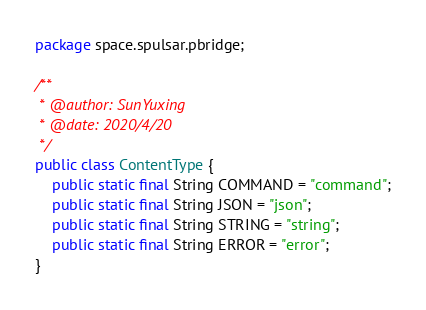<code> <loc_0><loc_0><loc_500><loc_500><_Java_>package space.spulsar.pbridge;

/**
 * @author: SunYuxing
 * @date: 2020/4/20
 */
public class ContentType {
    public static final String COMMAND = "command";
    public static final String JSON = "json";
    public static final String STRING = "string";
    public static final String ERROR = "error";
}
</code> 